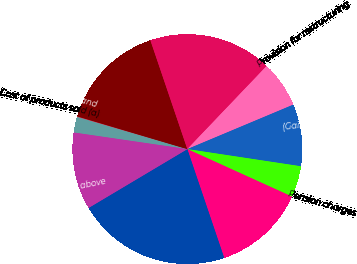<chart> <loc_0><loc_0><loc_500><loc_500><pie_chart><fcel>Cost of products sold (a)<fcel>Marketing selling and<fcel>License and asset acquisition<fcel>Research and development<fcel>Provision for restructuring<fcel>(Gain)/Loss on sale of<fcel>Pension charges<fcel>Other (income)/expense<fcel>Increase/(decrease) to pretax<fcel>Income tax on items above<nl><fcel>2.23%<fcel>0.07%<fcel>15.18%<fcel>17.34%<fcel>6.55%<fcel>8.71%<fcel>4.39%<fcel>13.02%<fcel>21.65%<fcel>10.86%<nl></chart> 